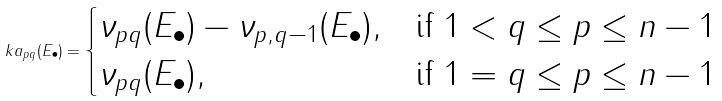<formula> <loc_0><loc_0><loc_500><loc_500>\ k a _ { p q } ( E _ { \bullet } ) = \begin{cases} \nu _ { p q } ( E _ { \bullet } ) - \nu _ { p , q - 1 } ( E _ { \bullet } ) , & \text {if } 1 < q \leq p \leq n - 1 \\ \nu _ { p q } ( E _ { \bullet } ) , & \text {if } 1 = q \leq p \leq n - 1 \end{cases}</formula> 